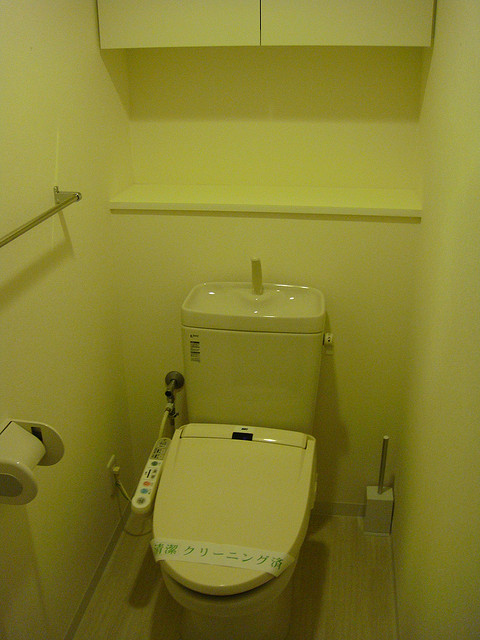<image>What does the sign say happened to the toilet? I don't know what the sign says happened to the toilet. It could be sanitized, defective, clogged, broken, clean, new or out of service. What does the sign say happened to the toilet? I am not sure what does the sign say happened to the toilet. It can be seen 'sanitized', 'defect', 'clogged', 'broke' or 'out of service'. 